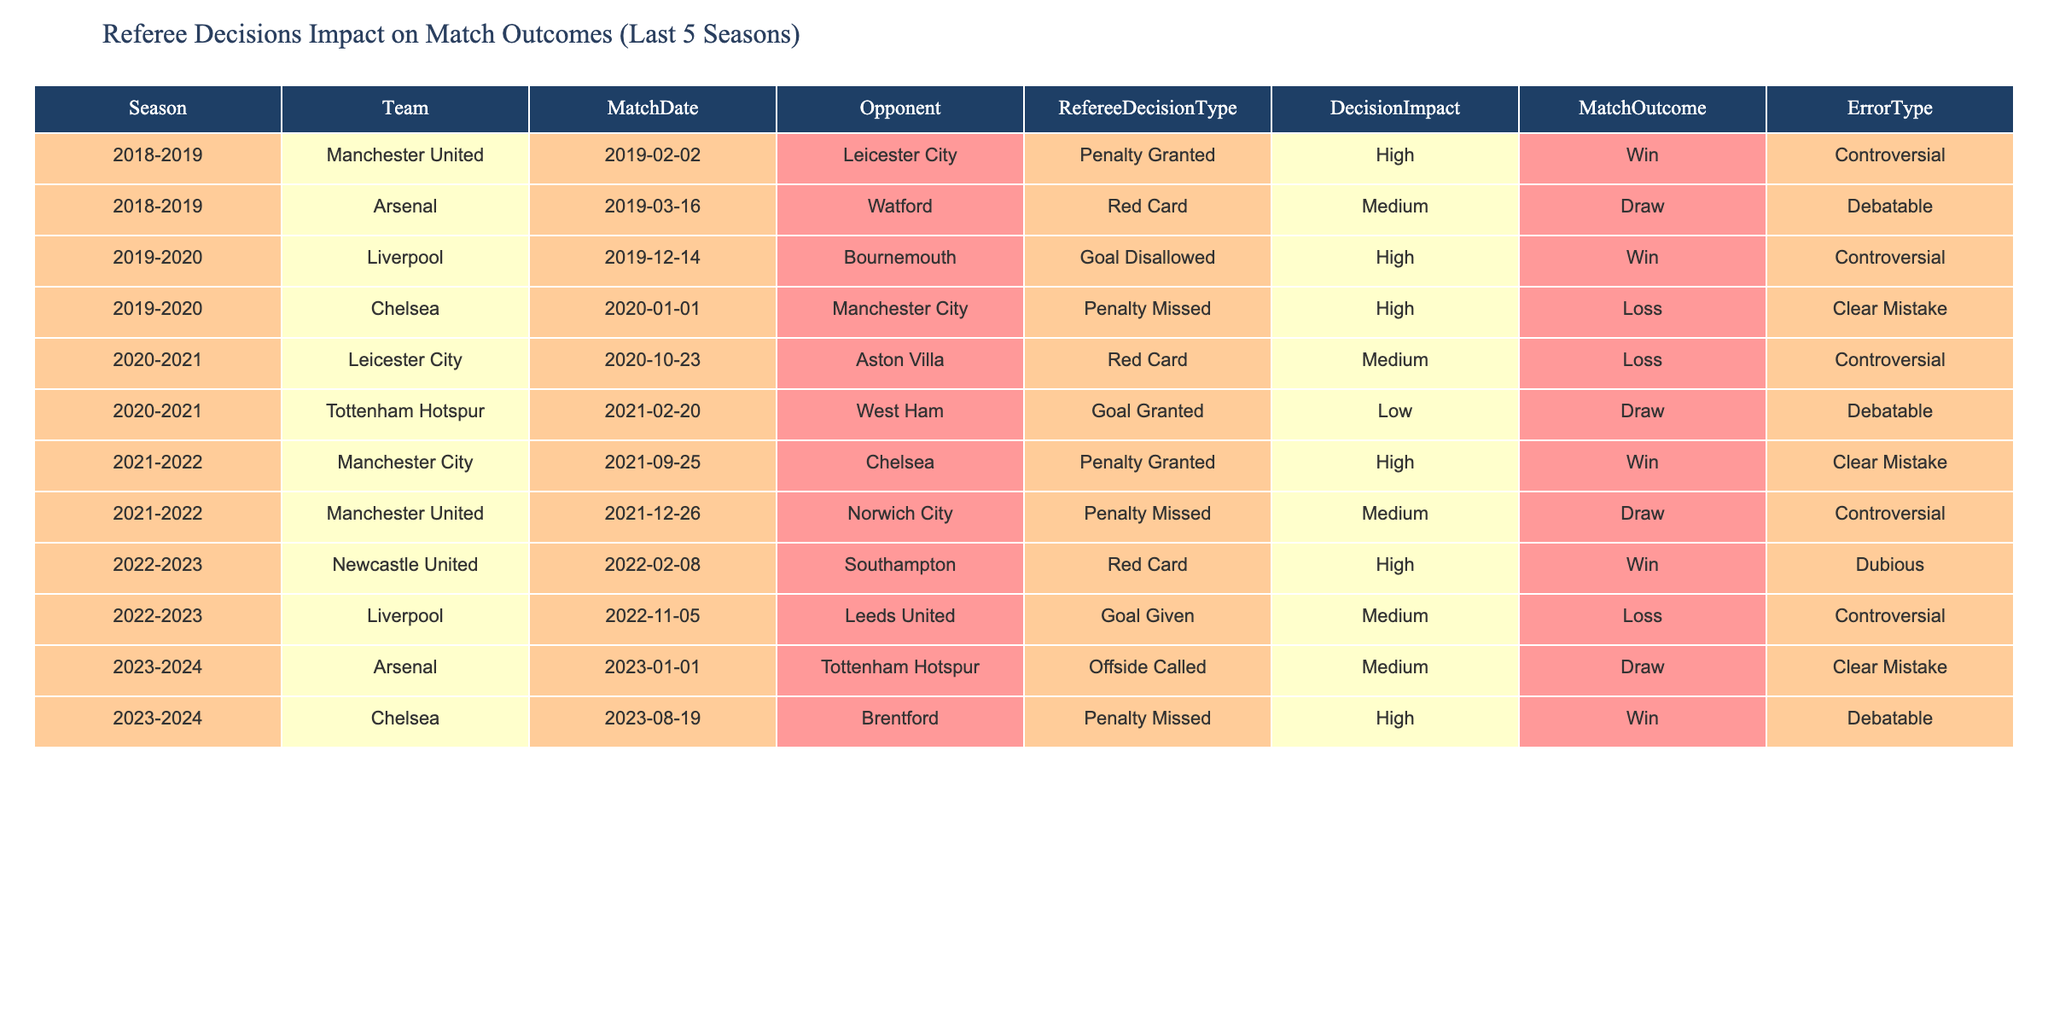What was the match outcome for Chelsea when they had a penalty missed? Referring to the table, Chelsea had a penalty missed against Manchester City on January 1, 2020, and the match outcome was a loss.
Answer: Loss How many matches ended in a draw due to controversial referee decisions? From the table, there are two matches that ended in a draw with controversial decisions: Arsenal vs. Watford and Manchester United vs. Norwich City.
Answer: 2 Was there a match where a red card decision had a high impact that resulted in a win? Looking at the table, yes, Newcastle United had a red card decision with high impact and won the match against Southampton on February 8, 2022.
Answer: Yes What teams had a penalty granted that resulted in a win? Analyzing the data, Manchester City against Chelsea and Manchester United against Leicester City both had penalties granted and won their respective matches.
Answer: Manchester City, Manchester United Which season did Liverpool experience the highest impact referee decision? By reviewing the data, the highest impact decision for Liverpool was the goal disallowed match against Bournemouth, which occurred in the 2019-2020 season.
Answer: 2019-2020 How many matches had 'Clear Mistake' as the error type, and what was the outcome of each? There are two matches marked as 'Clear Mistake': Chelsea’s penalty missed against Manchester City resulted in a loss, and Arsenal’s offside called against Tottenham resulted in a draw.
Answer: 2 matches: Loss, Draw Which team had the most medium impact decisions? From the table, Manchester United had two medium impact referee decisions (one penalty missed resulting in a draw and one goal disallowed resulting in a loss).
Answer: Manchester United If we combine all match outcomes, how many total wins did teams achieve from high impact decisions? The high impact decisions that resulted in wins are for Manchester United against Leicester City, Liverpool against Bournemouth, Manchester City against Chelsea, and Newcastle against Southampton. In total, that’s four win outcomes from high impact decisions.
Answer: 4Wins Was there any instance of a goal being both granted and disallowed in the same season? Looking through the data, yes, there was a goal granted to Tottenham Hotspur and a goal disallowed for Liverpool in the 2019-2020 season, indicating both scenarios occurred.
Answer: Yes How many penalties were missed across the dataset, and what were the outcomes of those matches? Two penalties were missed: Chelsea’s penalty against Manchester City which resulted in a loss, and Manchester United’s penalty against Norwich City which resulted in a draw.
Answer: 2 penalties missed: Loss, Draw 